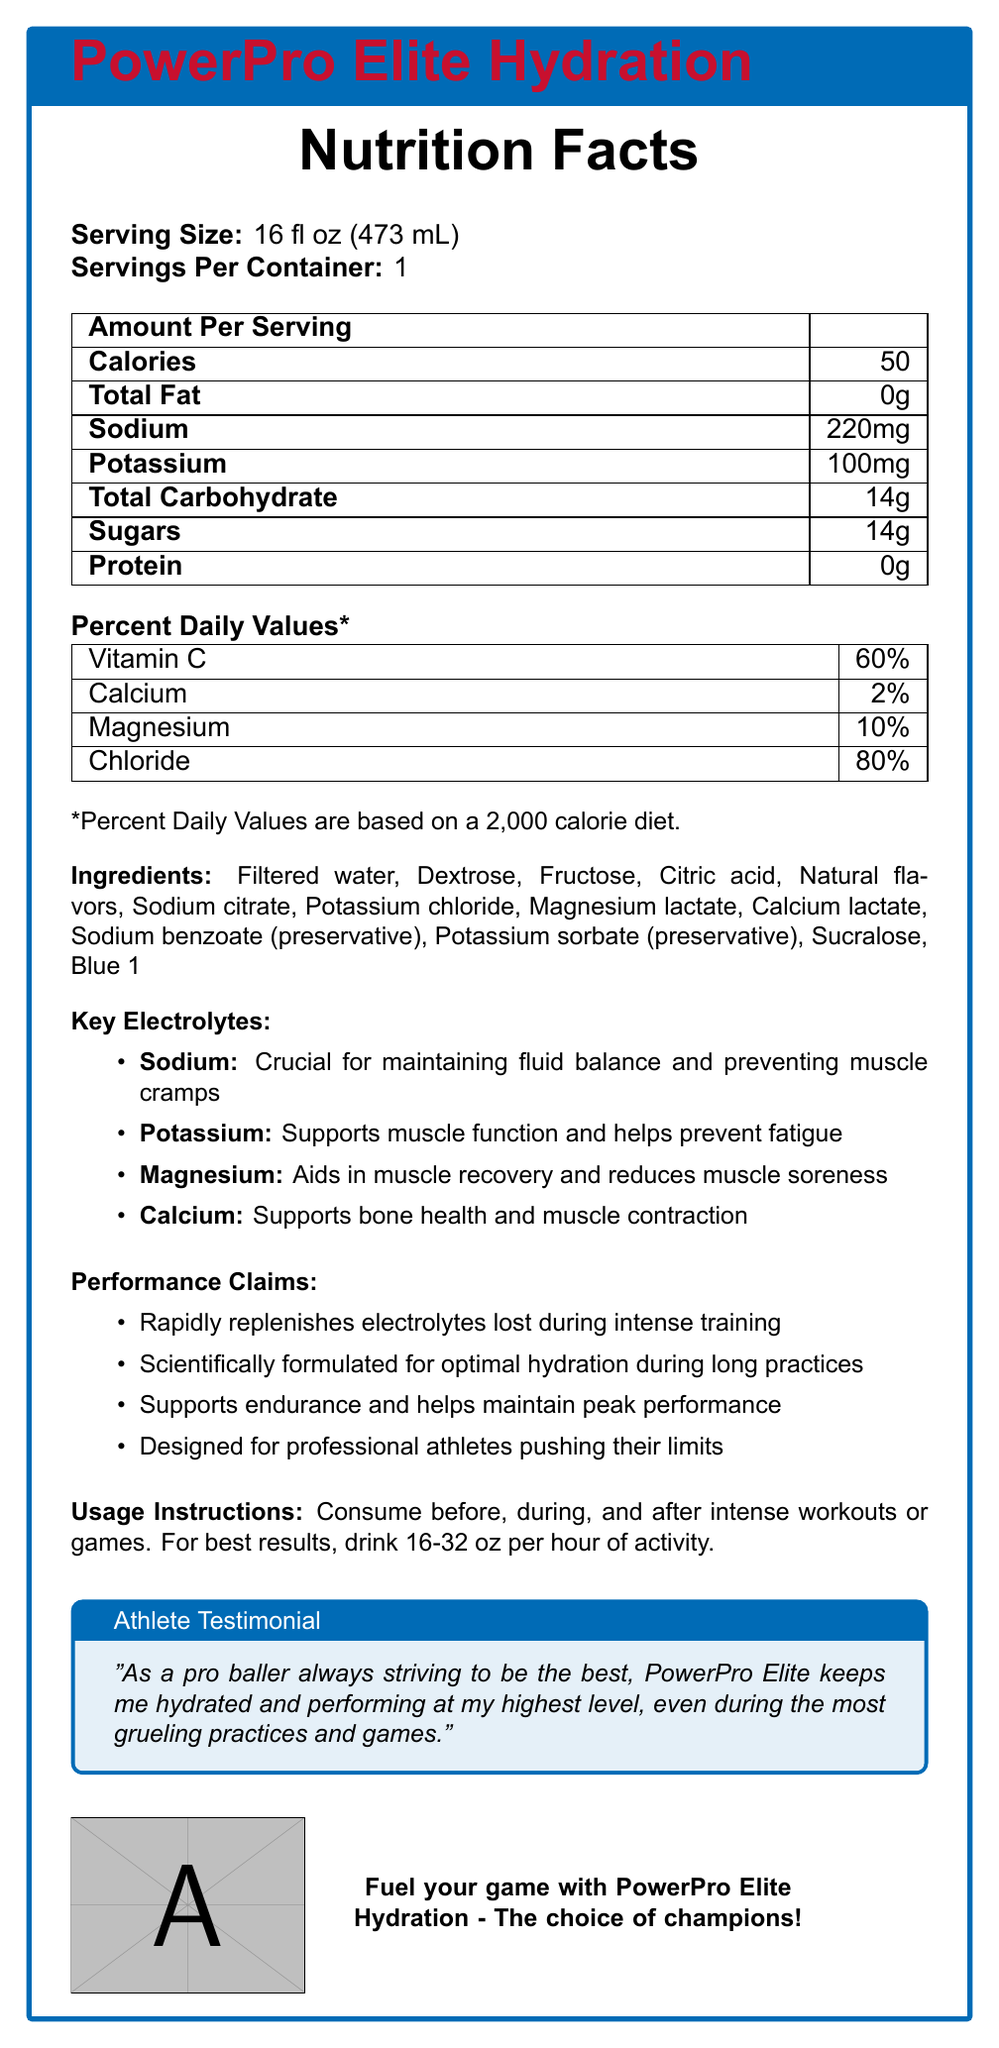What is the serving size of PowerPro Elite Hydration? The Nutrition Facts Label clearly states that the serving size is 16 fl oz (473 mL).
Answer: 16 fl oz (473 mL) How many calories are in one serving of PowerPro Elite Hydration? The Nutrition Facts section lists 50 calories per serving.
Answer: 50 What is the main function of sodium in this sports drink? The Key Electrolytes section mentions that sodium is crucial for maintaining fluid balance and preventing muscle cramps.
Answer: Maintaining fluid balance and preventing muscle cramps What percentage of Vitamin C does one serving provide based on the daily values? The Percent Daily Values section shows that it provides 60% of the daily value of Vitamin C.
Answer: 60% Which ingredients are used as preservatives in PowerPro Elite Hydration? The ingredients list includes Sodium benzoate and Potassium sorbate as preservatives.
Answer: Sodium benzoate and Potassium sorbate What is the total carbohydrate content per serving? A. 10g B. 14g C. 20g D. 30g The Nutrition Facts section shows that the total carbohydrate content per serving is 14 grams.
Answer: B. 14g What is one of the performance claims of PowerPro Elite Hydration? A. Increases muscle mass B. Rapidly replenishes electrolytes C. Reduces body fat D. Enhances sleep quality The Performance Claims section states that it "Rapidly replenishes electrolytes lost during intense training."
Answer: B. Rapidly replenishes electrolytes Is PowerPro Elite Hydration designed for professional athletes? The Performance Claims section mentions that it is "Designed for professional athletes pushing their limits."
Answer: Yes Describe the main features and benefits of PowerPro Elite Hydration. The document provides detailed information about the product, including its nutritional content, key electrolytes with their benefits, performance claims, and usage instructions, all aimed at professional athletes.
Answer: PowerPro Elite Hydration is a sports drink formulated for optimal hydration during long practices. It provides rapid electrolyte replenishment, supports endurance and helps maintain peak performance. It contains key electrolytes such as Sodium, Potassium, Magnesium, and Calcium, each with specific benefits for maintaining fluid balance, muscle function, and overall recovery. The product is designed for professional athletes and includes a testimonial emphasizing its effectiveness. The drink also contains 50 calories per 16 oz serving and is fortified with Vitamin C, among other ingredients. Are there any sugars in PowerPro Elite Hydration? The Nutrition Facts section indicates that there are 14 grams of sugars per serving.
Answer: Yes What is the recommended amount to drink per hour of activity? The Usage Instructions state that it is best to drink 16-32 oz per hour of activity.
Answer: 16-32 oz per hour Who gave the athlete testimonial included in the document? The document includes an athlete testimonial but does not specify who gave it.
Answer: Not enough information 